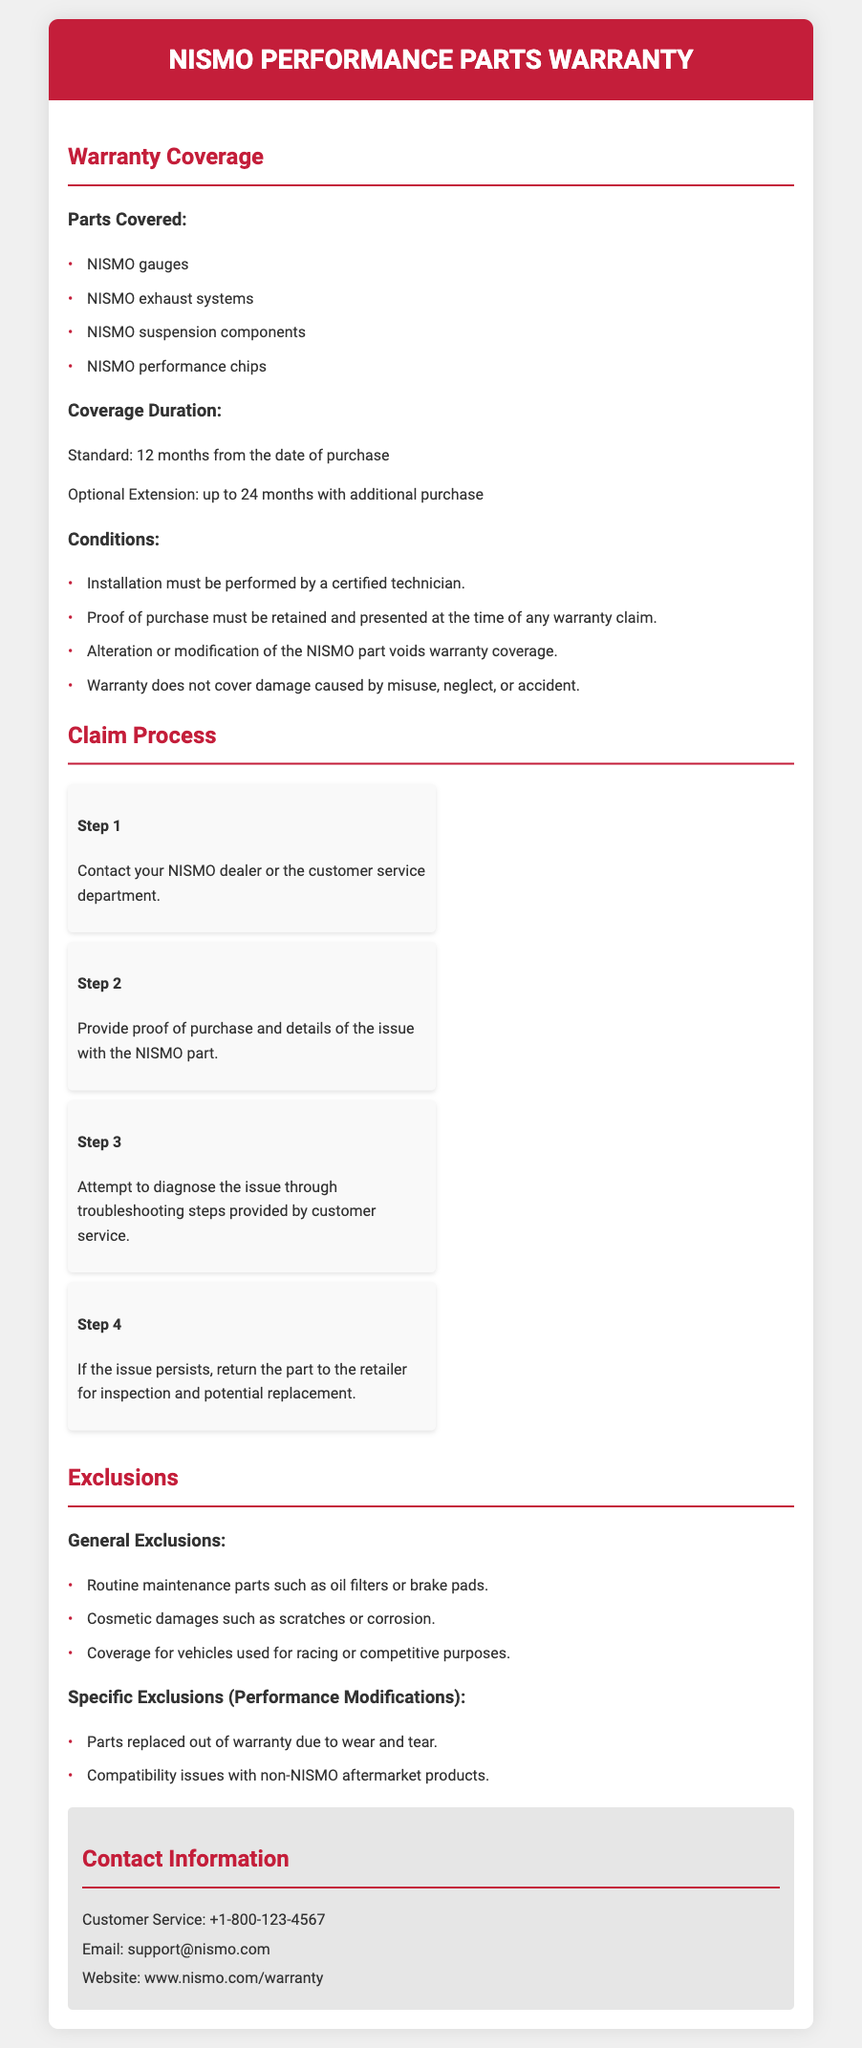what is the duration of the standard warranty? The standard warranty duration is specified in the document, which is 12 months from the date of purchase.
Answer: 12 months what parts are covered under warranty? The document lists specific parts that are covered under warranty, including NISMO gauges, exhaust systems, suspension components, and performance chips.
Answer: NISMO gauges, NISMO exhaust systems, NISMO suspension components, NISMO performance chips what is required for installation to maintain warranty coverage? The document states that installation must be performed by a certified technician to maintain warranty coverage.
Answer: Certified technician how long can the warranty be extended? The document mentions that the warranty can be extended with an additional purchase for up to 24 months.
Answer: 24 months what step involves providing proof of purchase? The document outlines a step in the claim process that requires providing proof of purchase and details of the issue with the NISMO part.
Answer: Step 2 what is not covered under the warranty? The warranty exclusions include routine maintenance parts and cosmetic damages, as specified in the document.
Answer: Routine maintenance parts, cosmetic damages what should you do if the issue persists? According to the document, if the issue persists after troubleshooting, the part should be returned to the retailer for inspection and potential replacement.
Answer: Return the part to the retailer which performance modifications are excluded from warranty coverage? The document lists specific exclusions related to performance modifications, including parts replaced due to wear and tear and compatibility issues with non-NISMO products.
Answer: Parts replaced out of warranty due to wear and tear, compatibility issues who can you contact for customer service? The document provides a customer service contact number for assistance, which is listed clearly.
Answer: +1-800-123-4567 